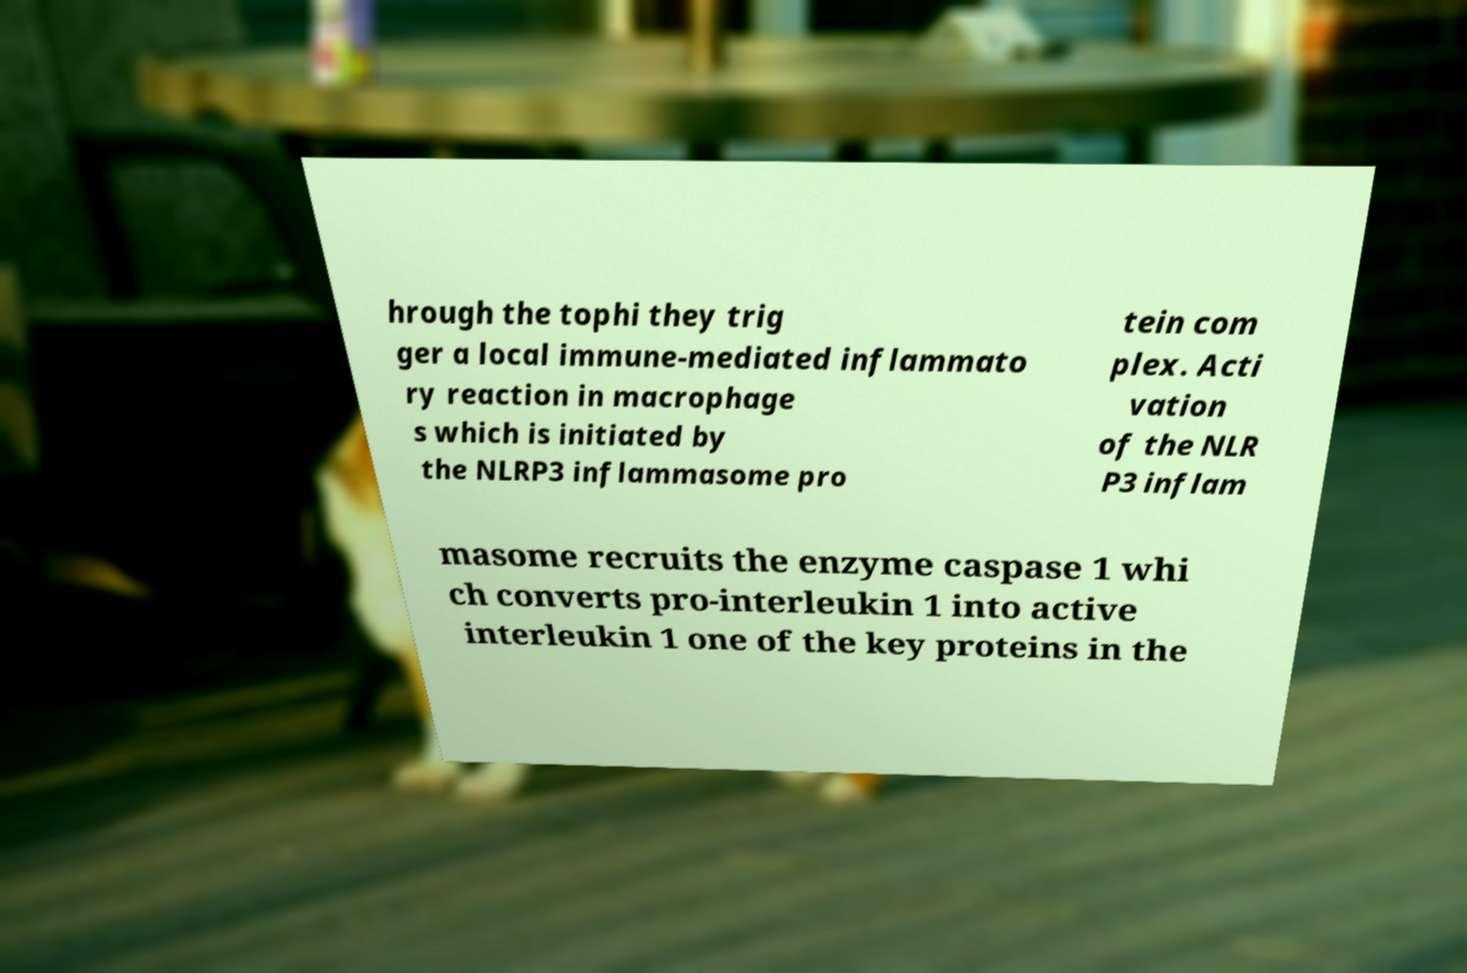Can you accurately transcribe the text from the provided image for me? hrough the tophi they trig ger a local immune-mediated inflammato ry reaction in macrophage s which is initiated by the NLRP3 inflammasome pro tein com plex. Acti vation of the NLR P3 inflam masome recruits the enzyme caspase 1 whi ch converts pro-interleukin 1 into active interleukin 1 one of the key proteins in the 